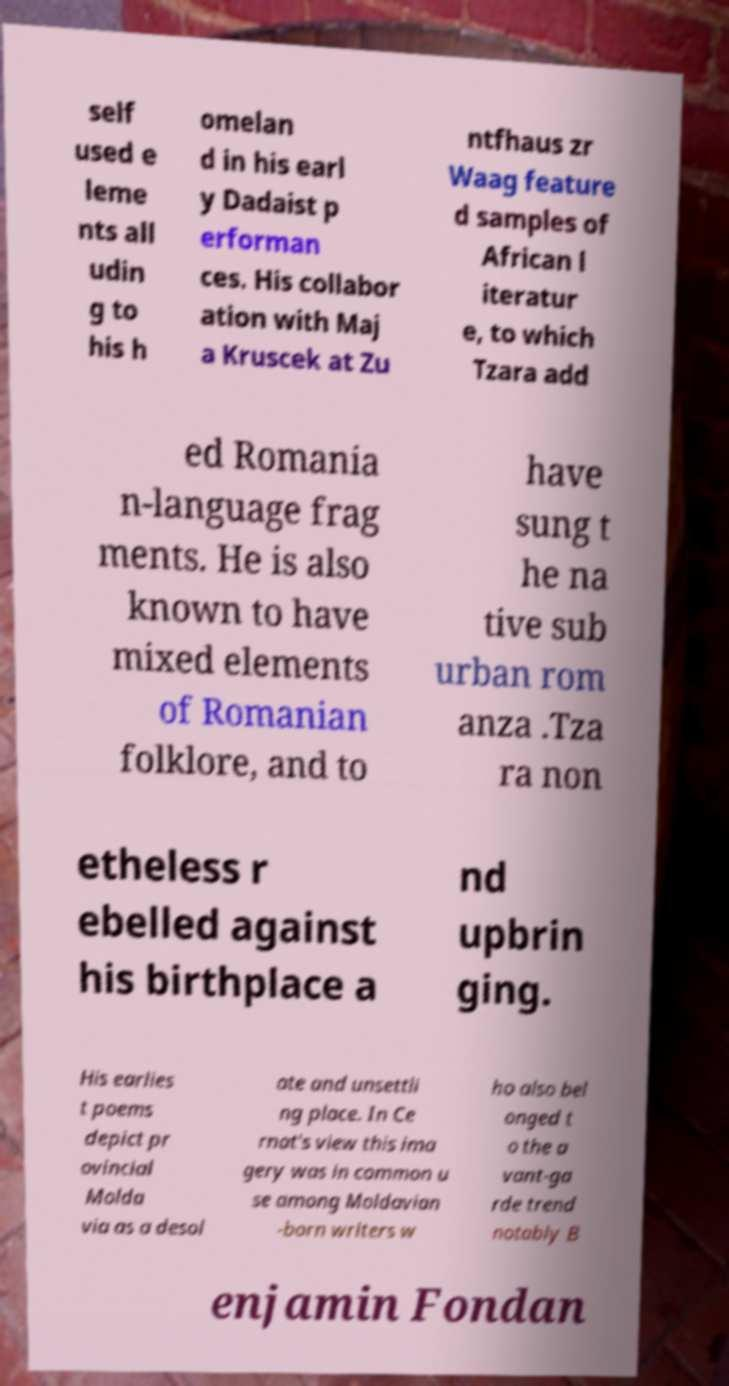Can you read and provide the text displayed in the image?This photo seems to have some interesting text. Can you extract and type it out for me? self used e leme nts all udin g to his h omelan d in his earl y Dadaist p erforman ces. His collabor ation with Maj a Kruscek at Zu ntfhaus zr Waag feature d samples of African l iteratur e, to which Tzara add ed Romania n-language frag ments. He is also known to have mixed elements of Romanian folklore, and to have sung t he na tive sub urban rom anza .Tza ra non etheless r ebelled against his birthplace a nd upbrin ging. His earlies t poems depict pr ovincial Molda via as a desol ate and unsettli ng place. In Ce rnat's view this ima gery was in common u se among Moldavian -born writers w ho also bel onged t o the a vant-ga rde trend notably B enjamin Fondan 